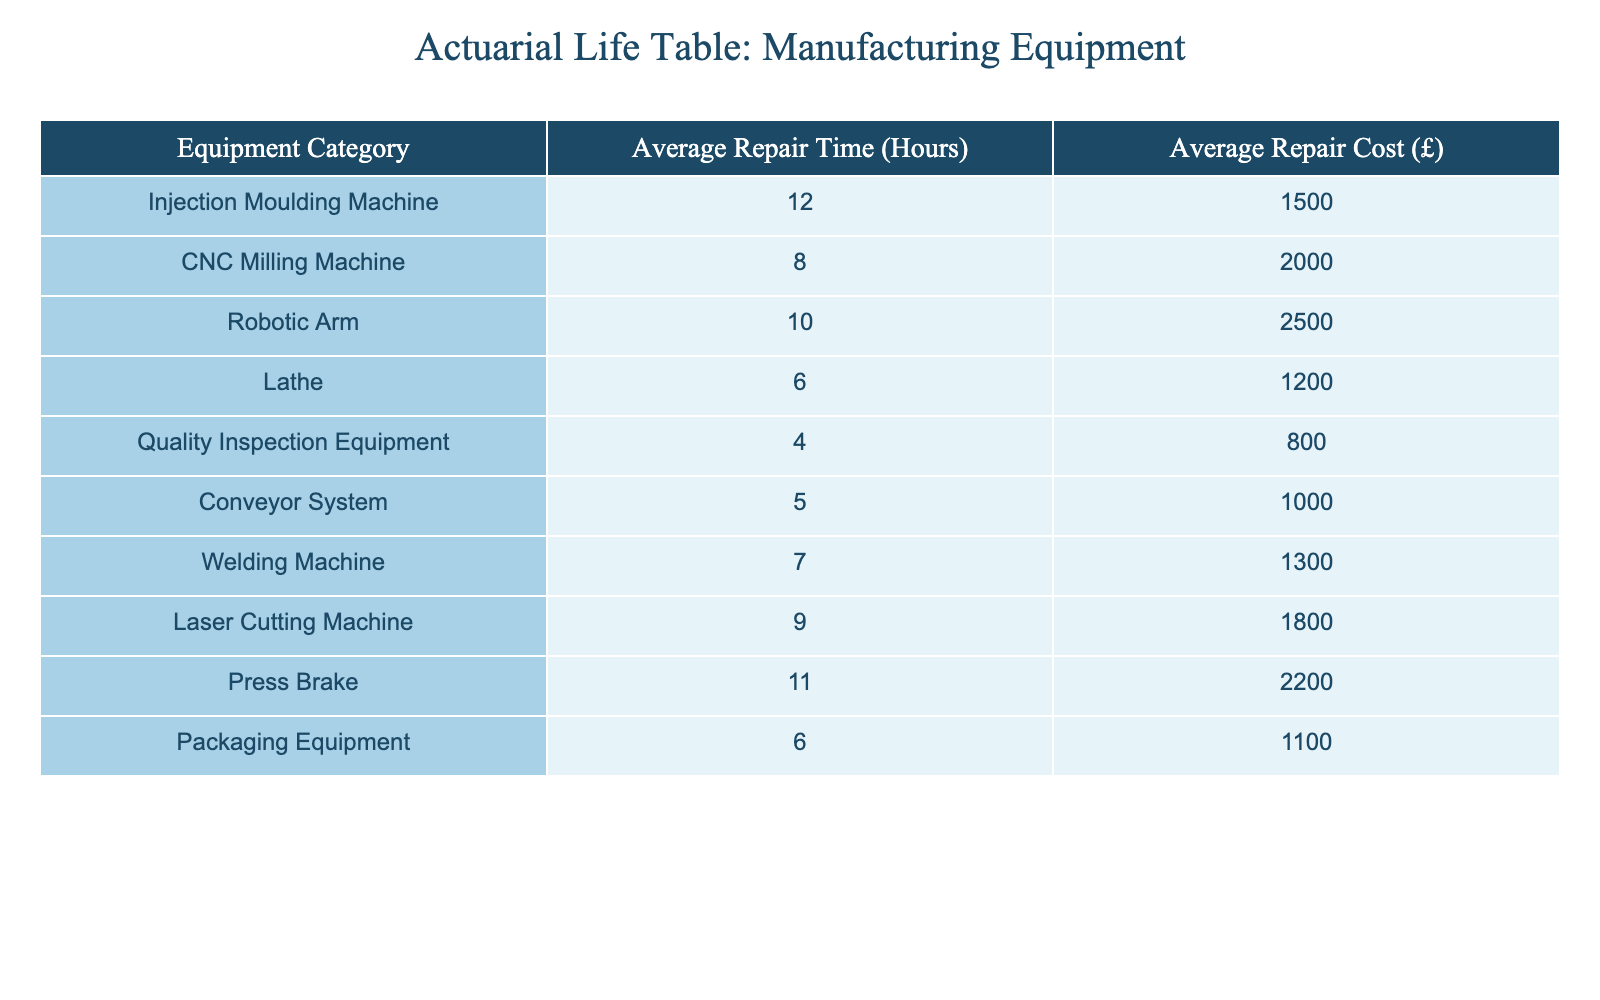What is the average repair time for a conveyor system? The table shows that the average repair time for a conveyor system is 5 hours, as stated directly in the relevant row.
Answer: 5 hours Which equipment category has the highest average repair cost? By comparing the average repair costs listed in the table, the robotic arm has the highest average repair cost of £2500.
Answer: £2500 What is the total average repair time for all equipment categories combined? To find the total average repair time, we sum all the individual average repair times: 12 + 8 + 10 + 6 + 4 + 5 + 7 + 9 + 11 + 6 = 78 hours. There are 10 categories, so the total average repair time is 78 / 10 = 7.8 hours.
Answer: 7.8 hours Is the average repair cost of a lathe lower than that of a quality inspection equipment? The average repair cost for a lathe is £1200, while for quality inspection equipment it is £800. Since £1200 is greater than £800, the statement is false.
Answer: No How many equipment categories have an average repair time of less than 8 hours? By reviewing the average repair times in the table, the lathe (6), quality inspection equipment (4), conveyor system (5), and welding machine (7) all have times less than 8 hours. That's a total of 4 categories.
Answer: 4 categories What is the average repair cost for the equipment with the lowest repair time? The equipment with the lowest repair time is quality inspection equipment at 4 hours. Its average repair cost is £800. Thus, the average repair cost for the equipment with the lowest repair time is £800.
Answer: £800 How much more on average does it cost to repair a CNC milling machine compared to a quality inspection equipment? The average repair cost for a CNC milling machine is £2000 and for quality inspection equipment is £800. The difference is £2000 - £800 = £1200, indicating that it costs £1200 more on average to repair a CNC milling machine.
Answer: £1200 Which equipment category has the lowest average repair time, and what is the corresponding repair cost? The equipment category with the lowest average repair time is quality inspection equipment, which takes an average of 4 hours to repair. The corresponding repair cost for this equipment is £800.
Answer: 4 hours, £800 What is the average of the average repair costs for all equipment categories? To find the average repair costs, we sum all the individual average repair costs: 1500 + 2000 + 2500 + 1200 + 800 + 1000 + 1300 + 1800 + 2200 + 1100 = 16200. There are 10 categories, so the total average repair cost is 16200 / 10 = £1620.
Answer: £1620 